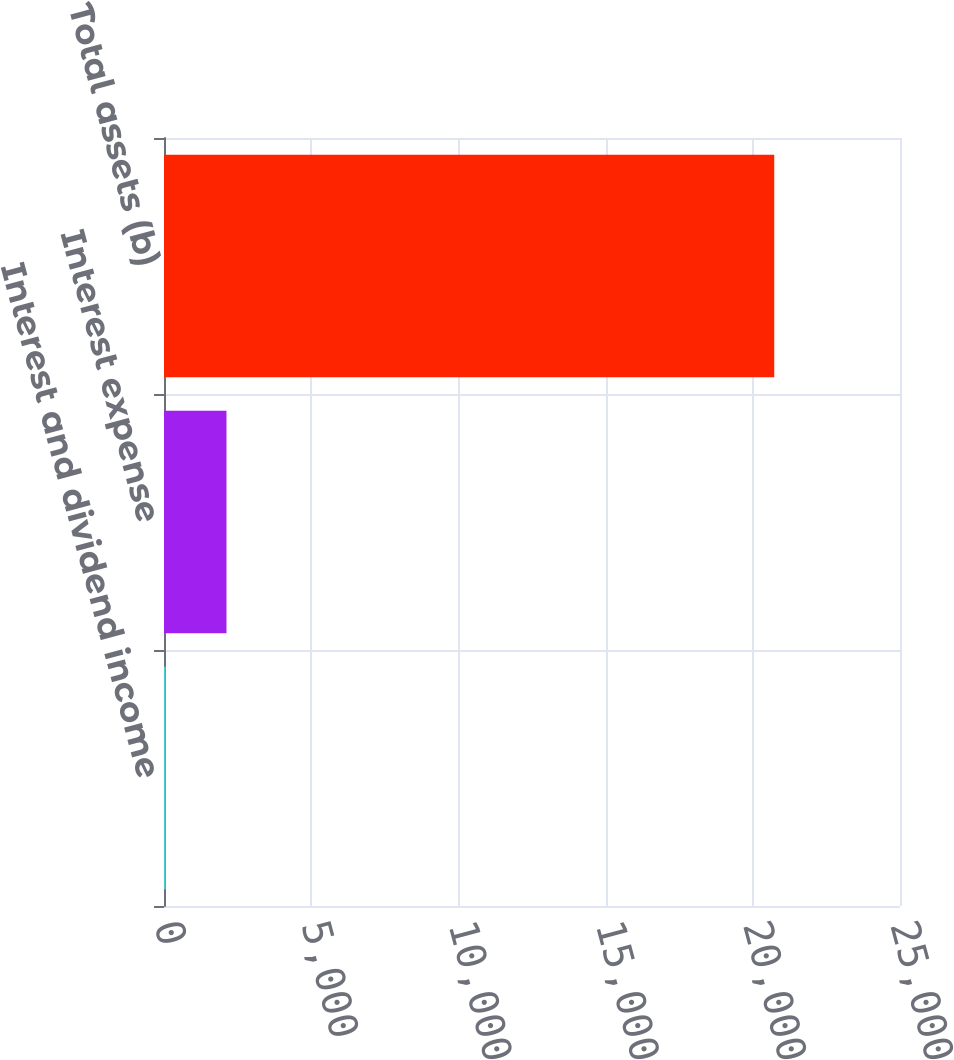Convert chart to OTSL. <chart><loc_0><loc_0><loc_500><loc_500><bar_chart><fcel>Interest and dividend income<fcel>Interest expense<fcel>Total assets (b)<nl><fcel>55<fcel>2122.3<fcel>20728<nl></chart> 